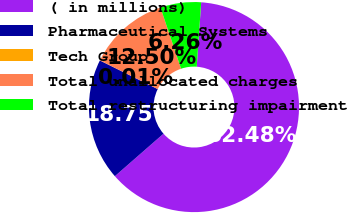Convert chart to OTSL. <chart><loc_0><loc_0><loc_500><loc_500><pie_chart><fcel>( in millions)<fcel>Pharmaceutical Systems<fcel>Tech Group<fcel>Total unallocated charges<fcel>Total restructuring impairment<nl><fcel>62.48%<fcel>18.75%<fcel>0.01%<fcel>12.5%<fcel>6.26%<nl></chart> 